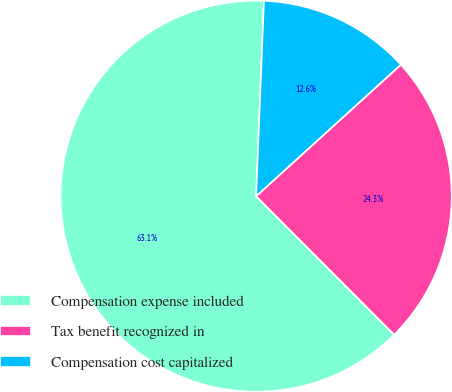<chart> <loc_0><loc_0><loc_500><loc_500><pie_chart><fcel>Compensation expense included<fcel>Tax benefit recognized in<fcel>Compensation cost capitalized<nl><fcel>63.11%<fcel>24.27%<fcel>12.62%<nl></chart> 